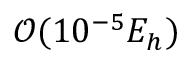<formula> <loc_0><loc_0><loc_500><loc_500>\mathcal { O } ( 1 0 ^ { - 5 } E _ { h } )</formula> 